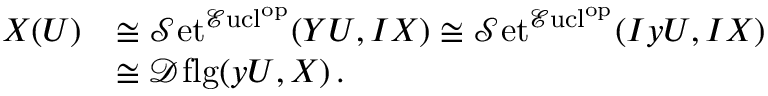Convert formula to latex. <formula><loc_0><loc_0><loc_500><loc_500>\begin{array} { r l } { X ( U ) } & { \cong { \mathcal { S } e t } ^ { { \mathcal { E } u c l } ^ { o p } } ( Y U , I X ) \cong { \mathcal { S } e t } ^ { { \mathcal { E } u c l } ^ { o p } } ( I y U , I X ) } \\ & { \cong { \mathcal { D } f l g } ( y U , X ) \, . } \end{array}</formula> 